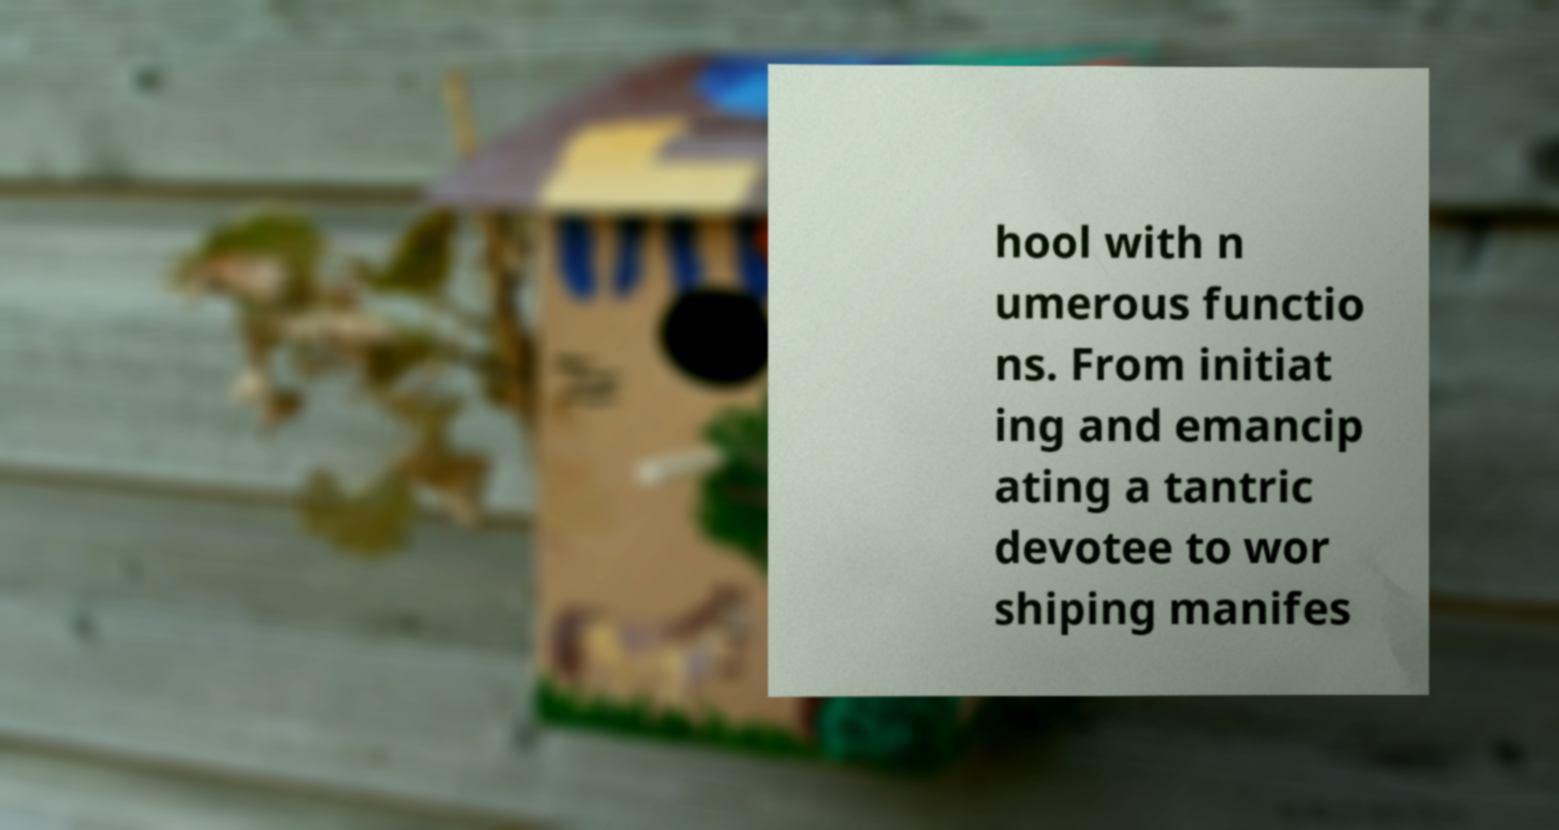For documentation purposes, I need the text within this image transcribed. Could you provide that? hool with n umerous functio ns. From initiat ing and emancip ating a tantric devotee to wor shiping manifes 